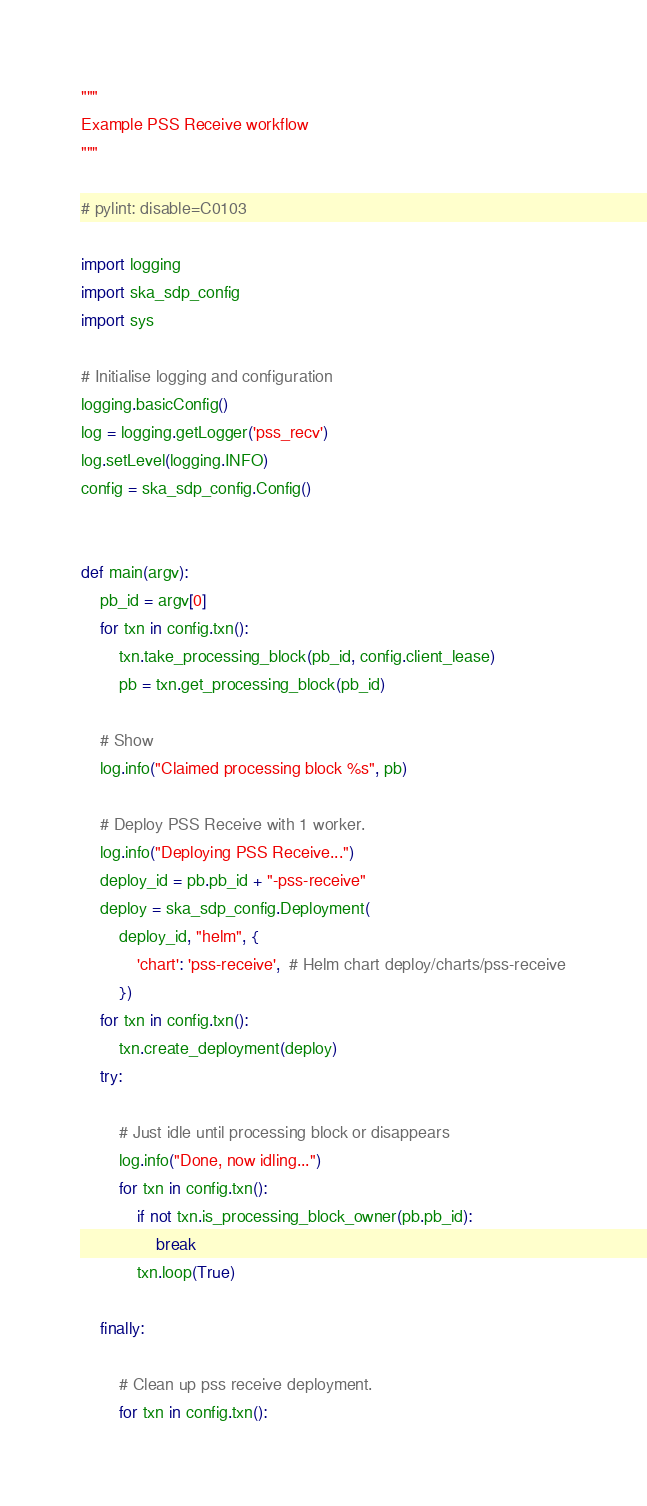<code> <loc_0><loc_0><loc_500><loc_500><_Python_>"""
Example PSS Receive workflow
"""

# pylint: disable=C0103

import logging
import ska_sdp_config
import sys

# Initialise logging and configuration
logging.basicConfig()
log = logging.getLogger('pss_recv')
log.setLevel(logging.INFO)
config = ska_sdp_config.Config()


def main(argv):
    pb_id = argv[0]
    for txn in config.txn():
        txn.take_processing_block(pb_id, config.client_lease)
        pb = txn.get_processing_block(pb_id)

    # Show
    log.info("Claimed processing block %s", pb)

    # Deploy PSS Receive with 1 worker.
    log.info("Deploying PSS Receive...")
    deploy_id = pb.pb_id + "-pss-receive"
    deploy = ska_sdp_config.Deployment(
        deploy_id, "helm", {
            'chart': 'pss-receive',  # Helm chart deploy/charts/pss-receive
        })
    for txn in config.txn():
        txn.create_deployment(deploy)
    try:

        # Just idle until processing block or disappears
        log.info("Done, now idling...")
        for txn in config.txn():
            if not txn.is_processing_block_owner(pb.pb_id):
                break
            txn.loop(True)

    finally:

        # Clean up pss receive deployment.
        for txn in config.txn():</code> 